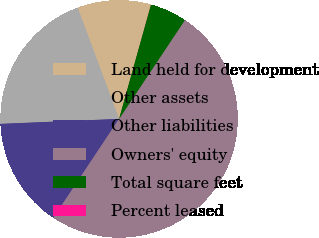Convert chart to OTSL. <chart><loc_0><loc_0><loc_500><loc_500><pie_chart><fcel>Land held for development<fcel>Other assets<fcel>Other liabilities<fcel>Owners' equity<fcel>Total square feet<fcel>Percent leased<nl><fcel>10.0%<fcel>20.0%<fcel>15.0%<fcel>49.99%<fcel>5.01%<fcel>0.01%<nl></chart> 